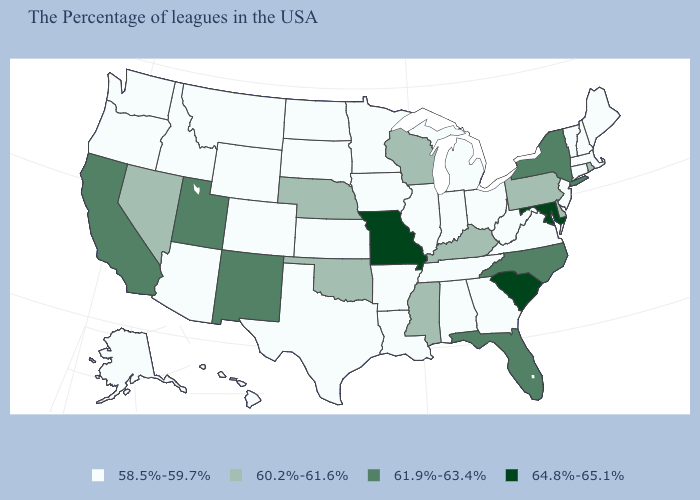Which states have the lowest value in the USA?
Write a very short answer. Maine, Massachusetts, New Hampshire, Vermont, Connecticut, New Jersey, Virginia, West Virginia, Ohio, Georgia, Michigan, Indiana, Alabama, Tennessee, Illinois, Louisiana, Arkansas, Minnesota, Iowa, Kansas, Texas, South Dakota, North Dakota, Wyoming, Colorado, Montana, Arizona, Idaho, Washington, Oregon, Alaska, Hawaii. What is the value of Washington?
Quick response, please. 58.5%-59.7%. Among the states that border Tennessee , does Missouri have the highest value?
Keep it brief. Yes. Name the states that have a value in the range 60.2%-61.6%?
Answer briefly. Rhode Island, Delaware, Pennsylvania, Kentucky, Wisconsin, Mississippi, Nebraska, Oklahoma, Nevada. Name the states that have a value in the range 61.9%-63.4%?
Keep it brief. New York, North Carolina, Florida, New Mexico, Utah, California. Is the legend a continuous bar?
Give a very brief answer. No. Does Washington have the highest value in the West?
Give a very brief answer. No. Does Wisconsin have a higher value than Florida?
Give a very brief answer. No. What is the lowest value in states that border Texas?
Answer briefly. 58.5%-59.7%. Name the states that have a value in the range 58.5%-59.7%?
Concise answer only. Maine, Massachusetts, New Hampshire, Vermont, Connecticut, New Jersey, Virginia, West Virginia, Ohio, Georgia, Michigan, Indiana, Alabama, Tennessee, Illinois, Louisiana, Arkansas, Minnesota, Iowa, Kansas, Texas, South Dakota, North Dakota, Wyoming, Colorado, Montana, Arizona, Idaho, Washington, Oregon, Alaska, Hawaii. What is the value of Arkansas?
Quick response, please. 58.5%-59.7%. Which states have the highest value in the USA?
Keep it brief. Maryland, South Carolina, Missouri. What is the value of Oklahoma?
Be succinct. 60.2%-61.6%. Name the states that have a value in the range 64.8%-65.1%?
Give a very brief answer. Maryland, South Carolina, Missouri. Does Montana have the lowest value in the West?
Write a very short answer. Yes. 